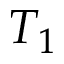<formula> <loc_0><loc_0><loc_500><loc_500>T _ { 1 }</formula> 